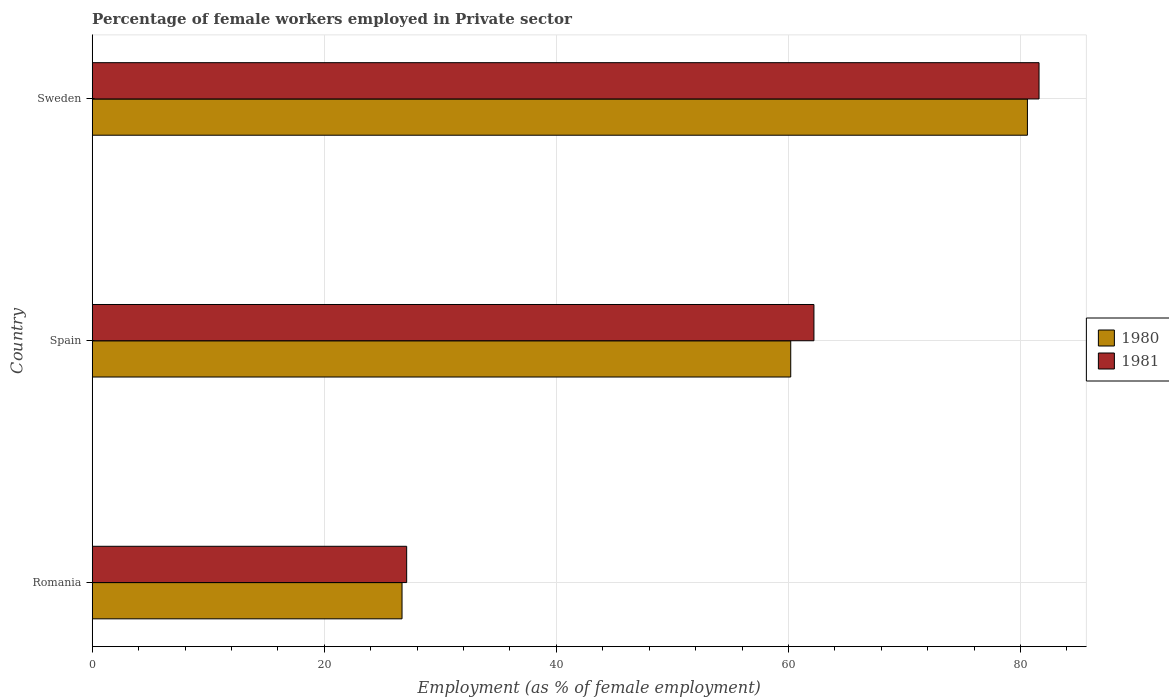How many groups of bars are there?
Ensure brevity in your answer.  3. Are the number of bars per tick equal to the number of legend labels?
Give a very brief answer. Yes. How many bars are there on the 3rd tick from the top?
Make the answer very short. 2. What is the label of the 2nd group of bars from the top?
Offer a very short reply. Spain. In how many cases, is the number of bars for a given country not equal to the number of legend labels?
Your answer should be compact. 0. What is the percentage of females employed in Private sector in 1981 in Sweden?
Offer a terse response. 81.6. Across all countries, what is the maximum percentage of females employed in Private sector in 1981?
Your answer should be very brief. 81.6. Across all countries, what is the minimum percentage of females employed in Private sector in 1981?
Your response must be concise. 27.1. In which country was the percentage of females employed in Private sector in 1980 maximum?
Your answer should be very brief. Sweden. In which country was the percentage of females employed in Private sector in 1981 minimum?
Keep it short and to the point. Romania. What is the total percentage of females employed in Private sector in 1981 in the graph?
Give a very brief answer. 170.9. What is the difference between the percentage of females employed in Private sector in 1980 in Romania and that in Sweden?
Provide a succinct answer. -53.9. What is the difference between the percentage of females employed in Private sector in 1980 in Spain and the percentage of females employed in Private sector in 1981 in Sweden?
Give a very brief answer. -21.4. What is the average percentage of females employed in Private sector in 1980 per country?
Ensure brevity in your answer.  55.83. What is the difference between the percentage of females employed in Private sector in 1980 and percentage of females employed in Private sector in 1981 in Sweden?
Provide a succinct answer. -1. In how many countries, is the percentage of females employed in Private sector in 1980 greater than 44 %?
Provide a succinct answer. 2. What is the ratio of the percentage of females employed in Private sector in 1980 in Romania to that in Spain?
Provide a short and direct response. 0.44. Is the percentage of females employed in Private sector in 1980 in Romania less than that in Spain?
Offer a very short reply. Yes. What is the difference between the highest and the second highest percentage of females employed in Private sector in 1980?
Provide a short and direct response. 20.4. What is the difference between the highest and the lowest percentage of females employed in Private sector in 1980?
Offer a very short reply. 53.9. In how many countries, is the percentage of females employed in Private sector in 1981 greater than the average percentage of females employed in Private sector in 1981 taken over all countries?
Your response must be concise. 2. What does the 1st bar from the top in Romania represents?
Provide a short and direct response. 1981. What does the 1st bar from the bottom in Sweden represents?
Provide a succinct answer. 1980. How many bars are there?
Give a very brief answer. 6. Are all the bars in the graph horizontal?
Your answer should be very brief. Yes. Does the graph contain grids?
Keep it short and to the point. Yes. Where does the legend appear in the graph?
Give a very brief answer. Center right. How are the legend labels stacked?
Make the answer very short. Vertical. What is the title of the graph?
Your response must be concise. Percentage of female workers employed in Private sector. Does "1989" appear as one of the legend labels in the graph?
Ensure brevity in your answer.  No. What is the label or title of the X-axis?
Your response must be concise. Employment (as % of female employment). What is the label or title of the Y-axis?
Make the answer very short. Country. What is the Employment (as % of female employment) of 1980 in Romania?
Your answer should be compact. 26.7. What is the Employment (as % of female employment) in 1981 in Romania?
Ensure brevity in your answer.  27.1. What is the Employment (as % of female employment) in 1980 in Spain?
Provide a succinct answer. 60.2. What is the Employment (as % of female employment) of 1981 in Spain?
Provide a short and direct response. 62.2. What is the Employment (as % of female employment) in 1980 in Sweden?
Make the answer very short. 80.6. What is the Employment (as % of female employment) of 1981 in Sweden?
Provide a short and direct response. 81.6. Across all countries, what is the maximum Employment (as % of female employment) of 1980?
Give a very brief answer. 80.6. Across all countries, what is the maximum Employment (as % of female employment) in 1981?
Make the answer very short. 81.6. Across all countries, what is the minimum Employment (as % of female employment) in 1980?
Offer a terse response. 26.7. Across all countries, what is the minimum Employment (as % of female employment) in 1981?
Offer a very short reply. 27.1. What is the total Employment (as % of female employment) of 1980 in the graph?
Your answer should be compact. 167.5. What is the total Employment (as % of female employment) in 1981 in the graph?
Provide a succinct answer. 170.9. What is the difference between the Employment (as % of female employment) of 1980 in Romania and that in Spain?
Your answer should be very brief. -33.5. What is the difference between the Employment (as % of female employment) of 1981 in Romania and that in Spain?
Your answer should be very brief. -35.1. What is the difference between the Employment (as % of female employment) in 1980 in Romania and that in Sweden?
Offer a very short reply. -53.9. What is the difference between the Employment (as % of female employment) of 1981 in Romania and that in Sweden?
Your response must be concise. -54.5. What is the difference between the Employment (as % of female employment) in 1980 in Spain and that in Sweden?
Offer a terse response. -20.4. What is the difference between the Employment (as % of female employment) in 1981 in Spain and that in Sweden?
Make the answer very short. -19.4. What is the difference between the Employment (as % of female employment) of 1980 in Romania and the Employment (as % of female employment) of 1981 in Spain?
Your answer should be very brief. -35.5. What is the difference between the Employment (as % of female employment) of 1980 in Romania and the Employment (as % of female employment) of 1981 in Sweden?
Offer a very short reply. -54.9. What is the difference between the Employment (as % of female employment) of 1980 in Spain and the Employment (as % of female employment) of 1981 in Sweden?
Keep it short and to the point. -21.4. What is the average Employment (as % of female employment) in 1980 per country?
Your answer should be compact. 55.83. What is the average Employment (as % of female employment) of 1981 per country?
Your answer should be compact. 56.97. What is the ratio of the Employment (as % of female employment) in 1980 in Romania to that in Spain?
Provide a short and direct response. 0.44. What is the ratio of the Employment (as % of female employment) in 1981 in Romania to that in Spain?
Ensure brevity in your answer.  0.44. What is the ratio of the Employment (as % of female employment) in 1980 in Romania to that in Sweden?
Your answer should be very brief. 0.33. What is the ratio of the Employment (as % of female employment) in 1981 in Romania to that in Sweden?
Your response must be concise. 0.33. What is the ratio of the Employment (as % of female employment) in 1980 in Spain to that in Sweden?
Your answer should be very brief. 0.75. What is the ratio of the Employment (as % of female employment) in 1981 in Spain to that in Sweden?
Ensure brevity in your answer.  0.76. What is the difference between the highest and the second highest Employment (as % of female employment) in 1980?
Your answer should be compact. 20.4. What is the difference between the highest and the lowest Employment (as % of female employment) in 1980?
Make the answer very short. 53.9. What is the difference between the highest and the lowest Employment (as % of female employment) of 1981?
Provide a succinct answer. 54.5. 